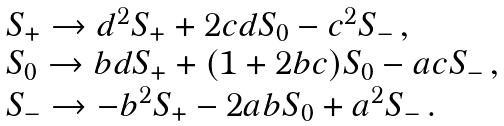Convert formula to latex. <formula><loc_0><loc_0><loc_500><loc_500>\begin{array} { l } { { S _ { + } \rightarrow d ^ { 2 } S _ { + } + 2 c d S _ { 0 } - c ^ { 2 } S _ { - } \, , } } \\ { { S _ { 0 } \rightarrow b d S _ { + } + ( 1 + 2 b c ) S _ { 0 } - a c S _ { - } \, , } } \\ { { S _ { - } \rightarrow - b ^ { 2 } S _ { + } - 2 a b S _ { 0 } + a ^ { 2 } S _ { - } \, . } } \end{array}</formula> 